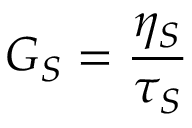Convert formula to latex. <formula><loc_0><loc_0><loc_500><loc_500>G _ { S } = \frac { \eta _ { S } } { \tau _ { S } }</formula> 